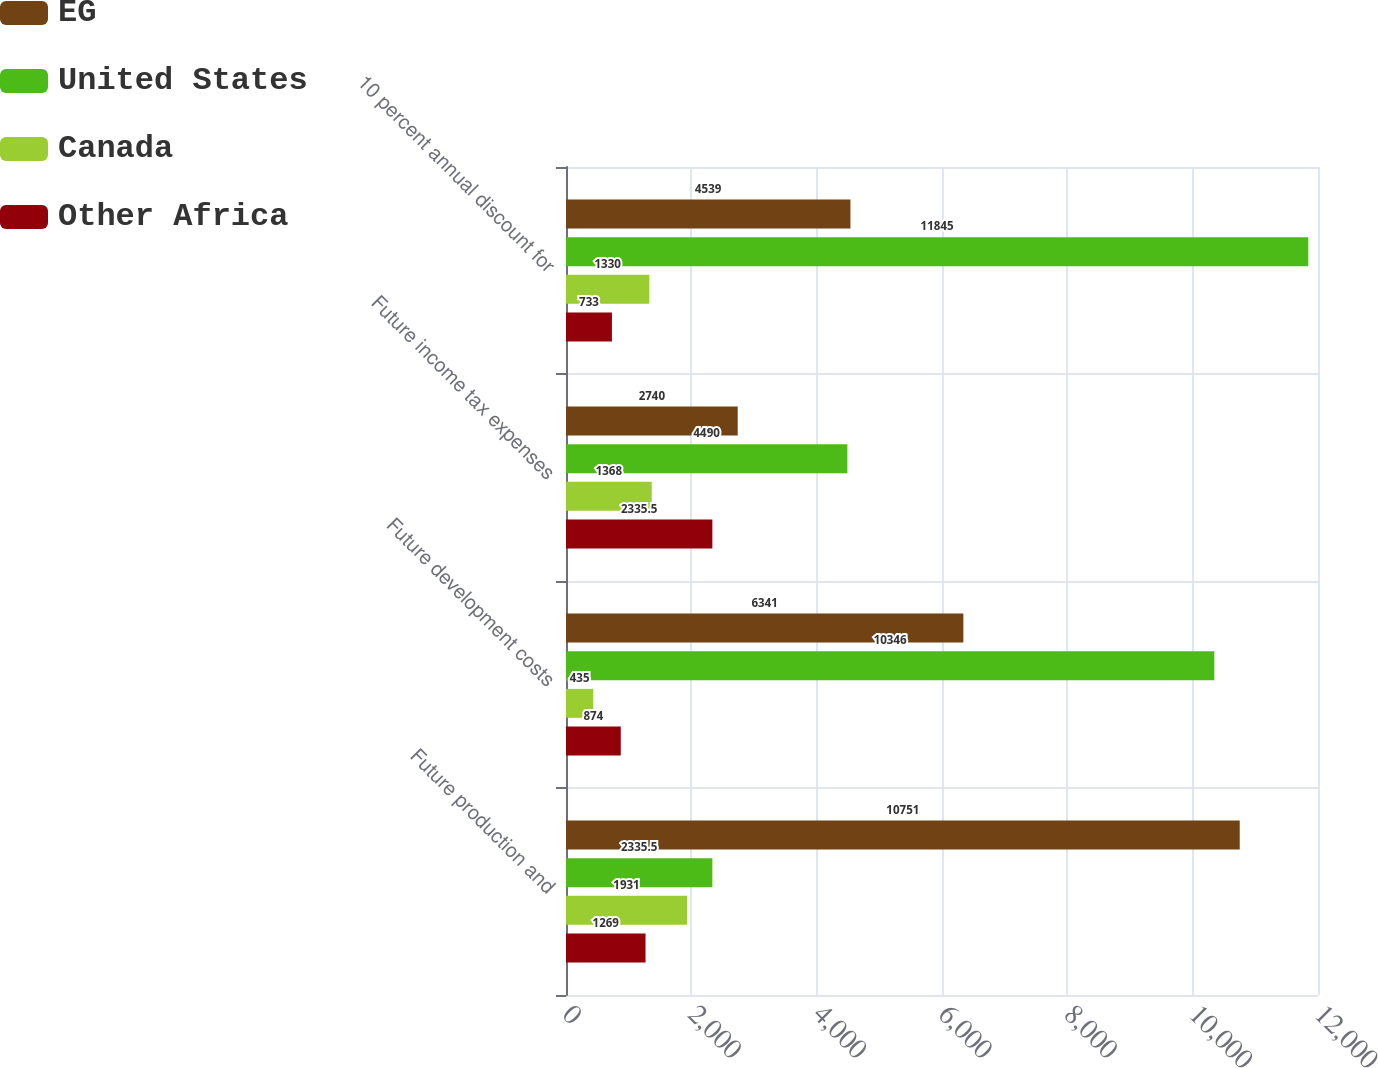Convert chart. <chart><loc_0><loc_0><loc_500><loc_500><stacked_bar_chart><ecel><fcel>Future production and<fcel>Future development costs<fcel>Future income tax expenses<fcel>10 percent annual discount for<nl><fcel>EG<fcel>10751<fcel>6341<fcel>2740<fcel>4539<nl><fcel>United States<fcel>2335.5<fcel>10346<fcel>4490<fcel>11845<nl><fcel>Canada<fcel>1931<fcel>435<fcel>1368<fcel>1330<nl><fcel>Other Africa<fcel>1269<fcel>874<fcel>2335.5<fcel>733<nl></chart> 